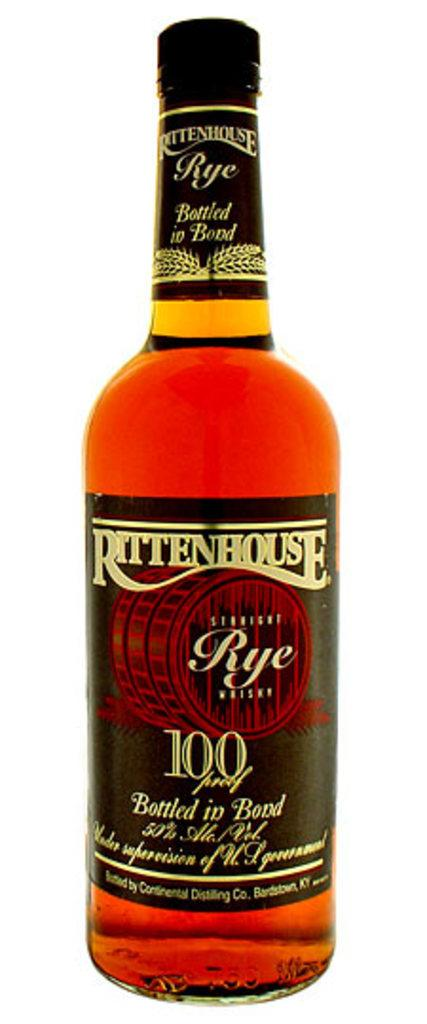What is the main object visible in the image? There is a wine bottle in the image. What type of land is the governor standing on in the image? There is no governor or land present in the image; it only features a wine bottle. 